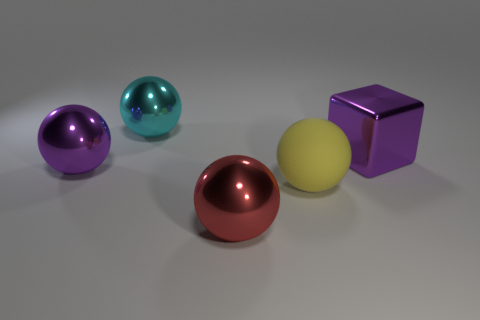Can you guess the relative positioning of these objects in terms of depth from the camera's perspective? Judging by their sizes and the intensity of the shadows, the red sphere appears to be closest to the camera, followed by the yellow sphere. The blue and purple spheres are positioned slightly further away, while the large purple block is the farthest of the group. 